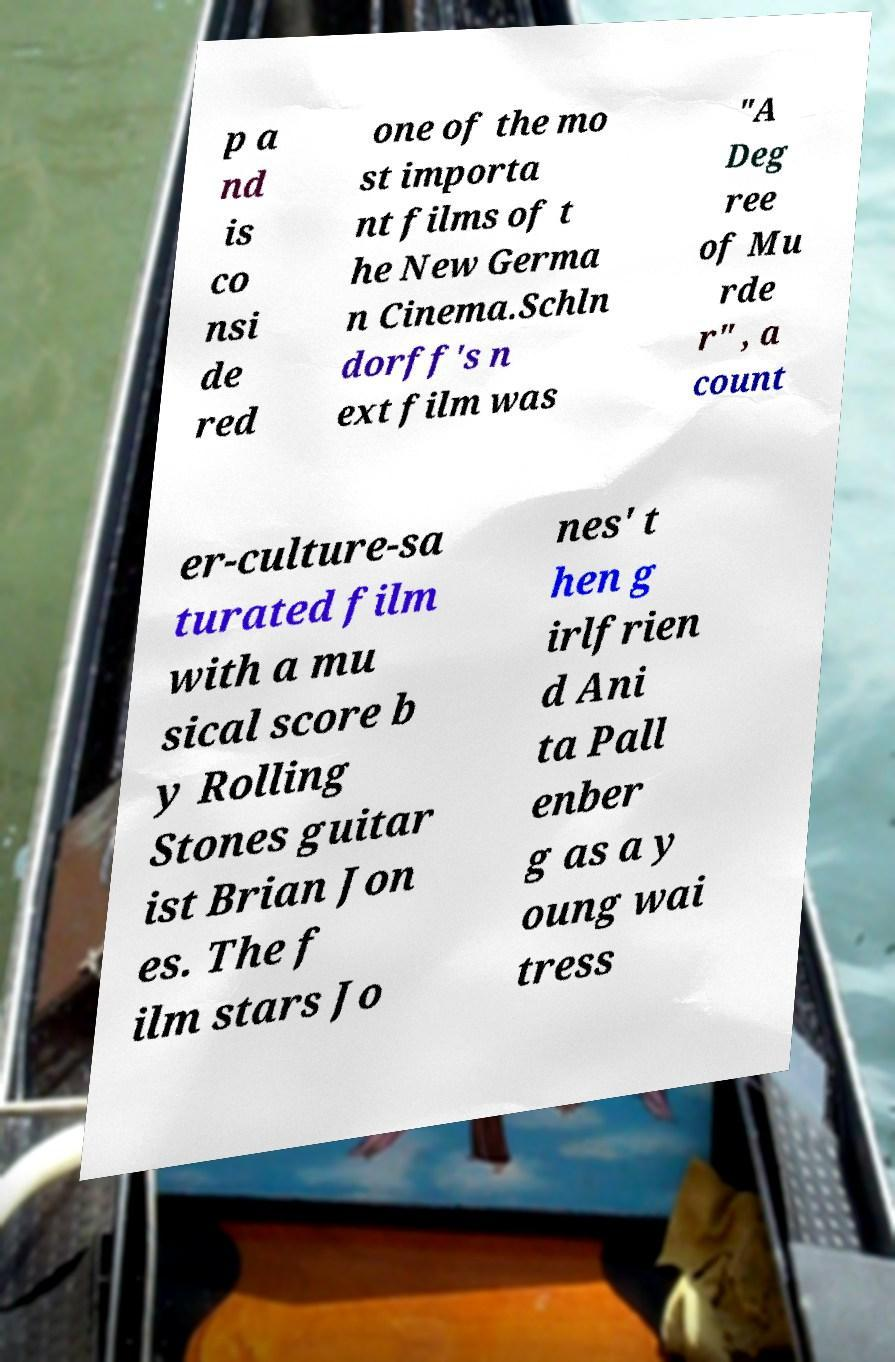There's text embedded in this image that I need extracted. Can you transcribe it verbatim? p a nd is co nsi de red one of the mo st importa nt films of t he New Germa n Cinema.Schln dorff's n ext film was "A Deg ree of Mu rde r" , a count er-culture-sa turated film with a mu sical score b y Rolling Stones guitar ist Brian Jon es. The f ilm stars Jo nes' t hen g irlfrien d Ani ta Pall enber g as a y oung wai tress 